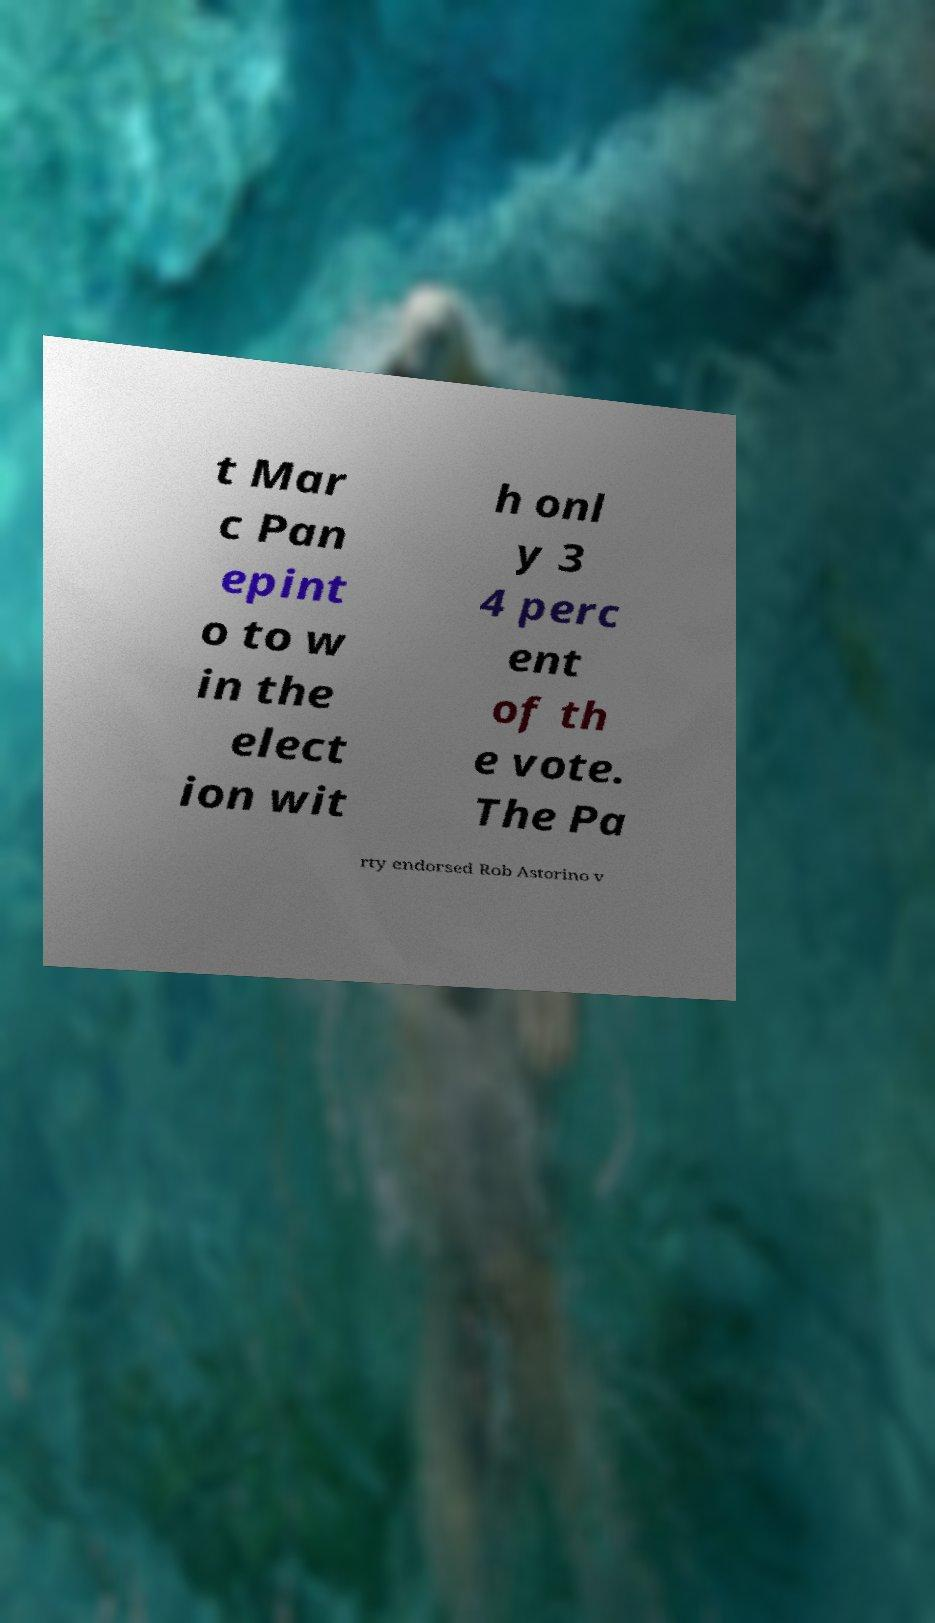There's text embedded in this image that I need extracted. Can you transcribe it verbatim? t Mar c Pan epint o to w in the elect ion wit h onl y 3 4 perc ent of th e vote. The Pa rty endorsed Rob Astorino v 